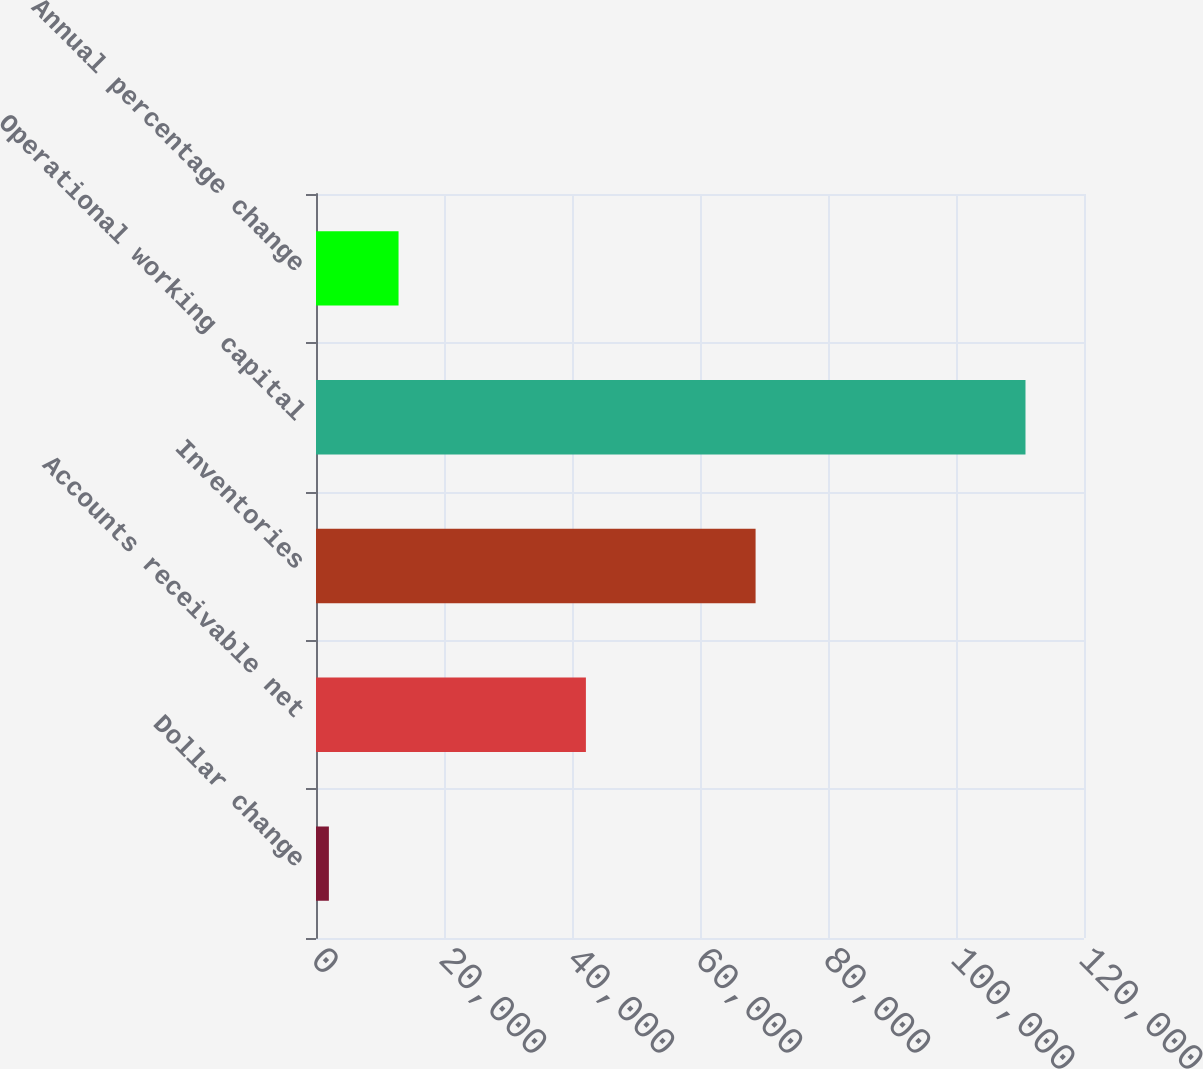Convert chart to OTSL. <chart><loc_0><loc_0><loc_500><loc_500><bar_chart><fcel>Dollar change<fcel>Accounts receivable net<fcel>Inventories<fcel>Operational working capital<fcel>Annual percentage change<nl><fcel>2013<fcel>42172<fcel>68685<fcel>110857<fcel>12897.4<nl></chart> 